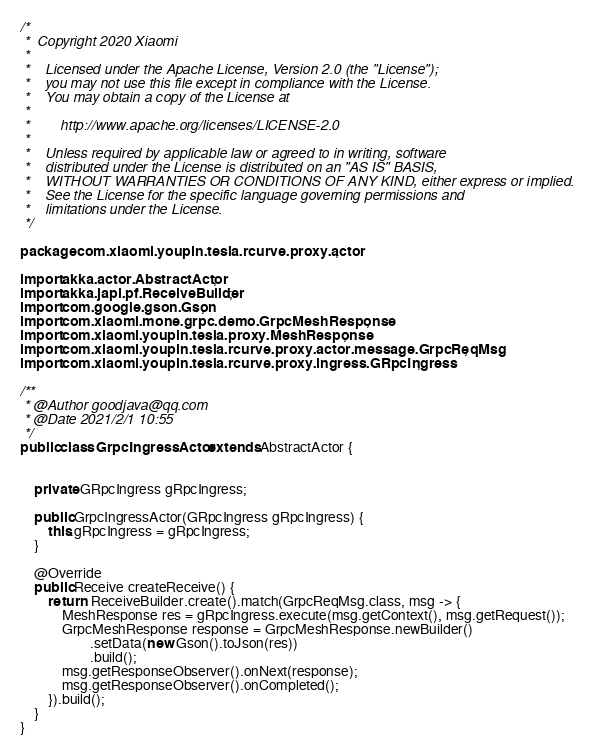<code> <loc_0><loc_0><loc_500><loc_500><_Java_>/*
 *  Copyright 2020 Xiaomi
 *
 *    Licensed under the Apache License, Version 2.0 (the "License");
 *    you may not use this file except in compliance with the License.
 *    You may obtain a copy of the License at
 *
 *        http://www.apache.org/licenses/LICENSE-2.0
 *
 *    Unless required by applicable law or agreed to in writing, software
 *    distributed under the License is distributed on an "AS IS" BASIS,
 *    WITHOUT WARRANTIES OR CONDITIONS OF ANY KIND, either express or implied.
 *    See the License for the specific language governing permissions and
 *    limitations under the License.
 */

package com.xiaomi.youpin.tesla.rcurve.proxy.actor;

import akka.actor.AbstractActor;
import akka.japi.pf.ReceiveBuilder;
import com.google.gson.Gson;
import com.xiaomi.mone.grpc.demo.GrpcMeshResponse;
import com.xiaomi.youpin.tesla.proxy.MeshResponse;
import com.xiaomi.youpin.tesla.rcurve.proxy.actor.message.GrpcReqMsg;
import com.xiaomi.youpin.tesla.rcurve.proxy.ingress.GRpcIngress;

/**
 * @Author goodjava@qq.com
 * @Date 2021/2/1 10:55
 */
public class GrpcIngressActor extends AbstractActor {


    private GRpcIngress gRpcIngress;

    public GrpcIngressActor(GRpcIngress gRpcIngress) {
        this.gRpcIngress = gRpcIngress;
    }

    @Override
    public Receive createReceive() {
        return  ReceiveBuilder.create().match(GrpcReqMsg.class, msg -> {
            MeshResponse res = gRpcIngress.execute(msg.getContext(), msg.getRequest());
            GrpcMeshResponse response = GrpcMeshResponse.newBuilder()
                    .setData(new Gson().toJson(res))
                    .build();
            msg.getResponseObserver().onNext(response);
            msg.getResponseObserver().onCompleted();
        }).build();
    }
}
</code> 